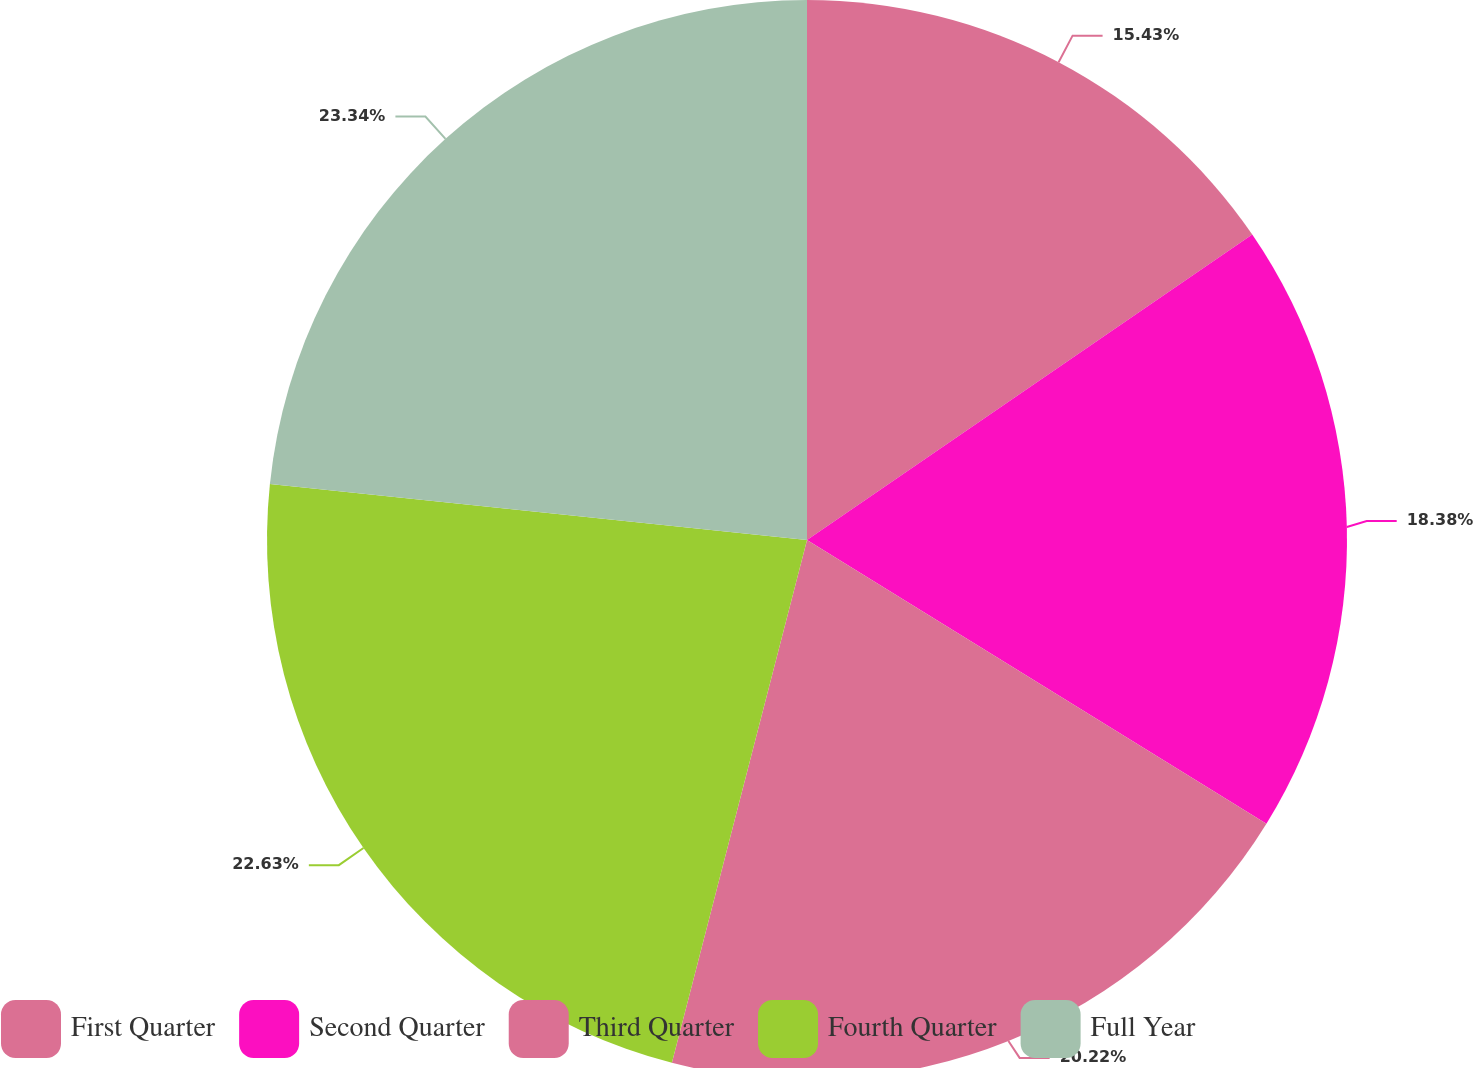Convert chart to OTSL. <chart><loc_0><loc_0><loc_500><loc_500><pie_chart><fcel>First Quarter<fcel>Second Quarter<fcel>Third Quarter<fcel>Fourth Quarter<fcel>Full Year<nl><fcel>15.43%<fcel>18.38%<fcel>20.22%<fcel>22.63%<fcel>23.35%<nl></chart> 